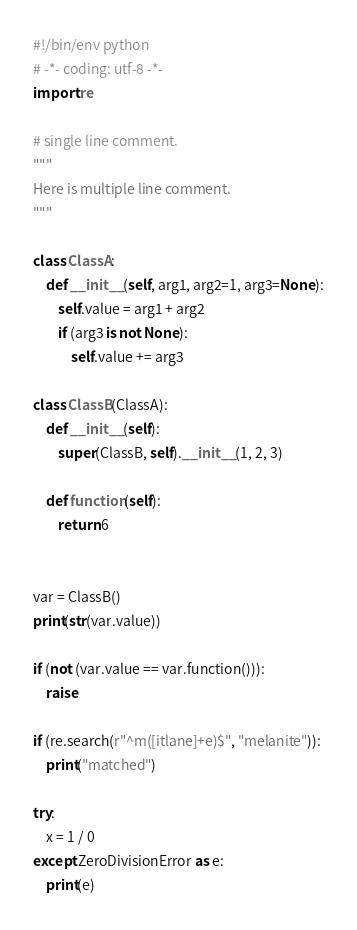<code> <loc_0><loc_0><loc_500><loc_500><_Python_>#!/bin/env python
# -*- coding: utf-8 -*-
import re

# single line comment.
"""
Here is multiple line comment.
"""

class ClassA:
    def __init__(self, arg1, arg2=1, arg3=None):
        self.value = arg1 + arg2
        if (arg3 is not None):
            self.value += arg3

class ClassB(ClassA):
    def __init__(self):
        super(ClassB, self).__init__(1, 2, 3)

    def function(self):
        return 6


var = ClassB()
print(str(var.value))

if (not (var.value == var.function())):
    raise

if (re.search(r"^m([itlane]+e)$", "melanite")):
    print("matched")

try:
    x = 1 / 0
except ZeroDivisionError as e:
    print(e)
</code> 